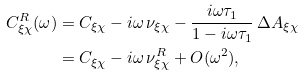Convert formula to latex. <formula><loc_0><loc_0><loc_500><loc_500>C _ { \xi \chi } ^ { R } ( \omega ) & = C _ { \xi \chi } - i \omega \, \nu _ { \xi \chi } - \frac { i \omega \tau _ { 1 } } { 1 - i \omega \tau _ { 1 } } \, \Delta A _ { \xi \chi } \\ & = C _ { \xi \chi } - i \omega \, \nu _ { \xi \chi } ^ { R } + O ( \omega ^ { 2 } ) ,</formula> 